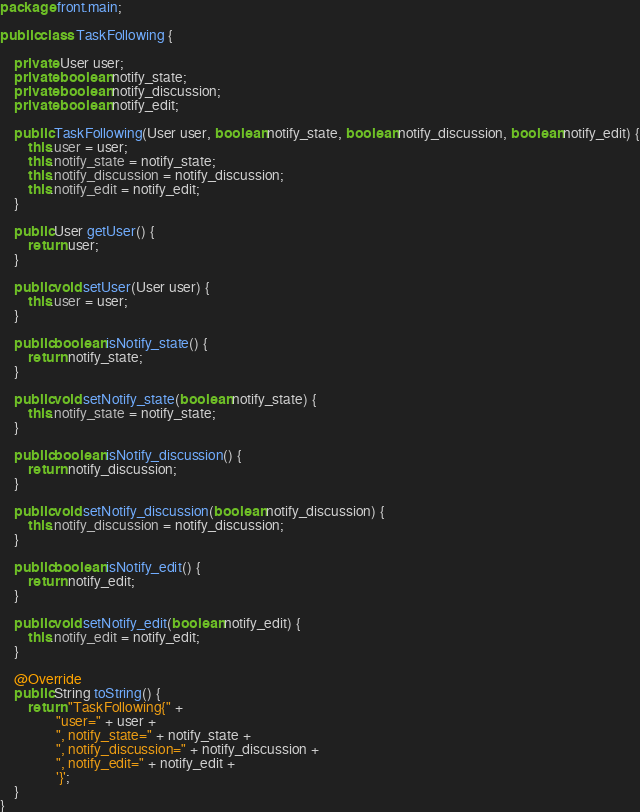Convert code to text. <code><loc_0><loc_0><loc_500><loc_500><_Java_>package front.main;

public class TaskFollowing {

    private User user;
    private boolean notify_state;
    private boolean notify_discussion;
    private boolean notify_edit;

    public TaskFollowing(User user, boolean notify_state, boolean notify_discussion, boolean notify_edit) {
        this.user = user;
        this.notify_state = notify_state;
        this.notify_discussion = notify_discussion;
        this.notify_edit = notify_edit;
    }

    public User getUser() {
        return user;
    }

    public void setUser(User user) {
        this.user = user;
    }

    public boolean isNotify_state() {
        return notify_state;
    }

    public void setNotify_state(boolean notify_state) {
        this.notify_state = notify_state;
    }

    public boolean isNotify_discussion() {
        return notify_discussion;
    }

    public void setNotify_discussion(boolean notify_discussion) {
        this.notify_discussion = notify_discussion;
    }

    public boolean isNotify_edit() {
        return notify_edit;
    }

    public void setNotify_edit(boolean notify_edit) {
        this.notify_edit = notify_edit;
    }

    @Override
    public String toString() {
        return "TaskFollowing{" +
                "user=" + user +
                ", notify_state=" + notify_state +
                ", notify_discussion=" + notify_discussion +
                ", notify_edit=" + notify_edit +
                '}';
    }
}
</code> 